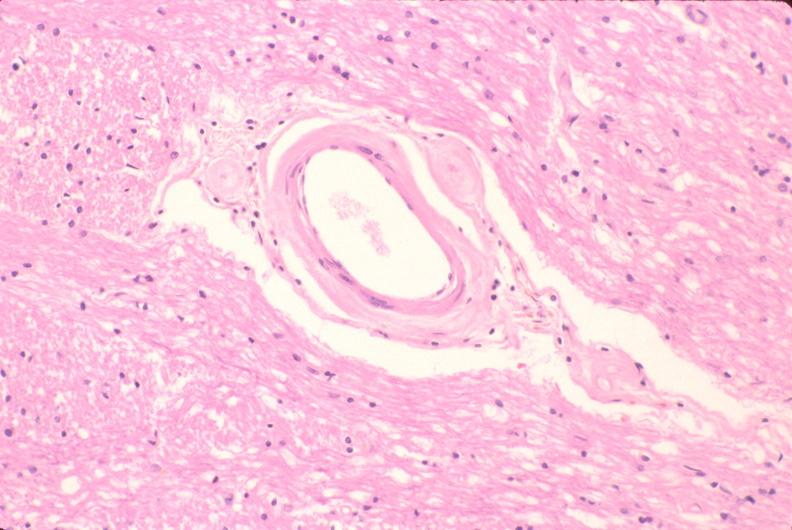does spinal column show brain, microvessel hyalinization, diabetes mellitus?
Answer the question using a single word or phrase. No 